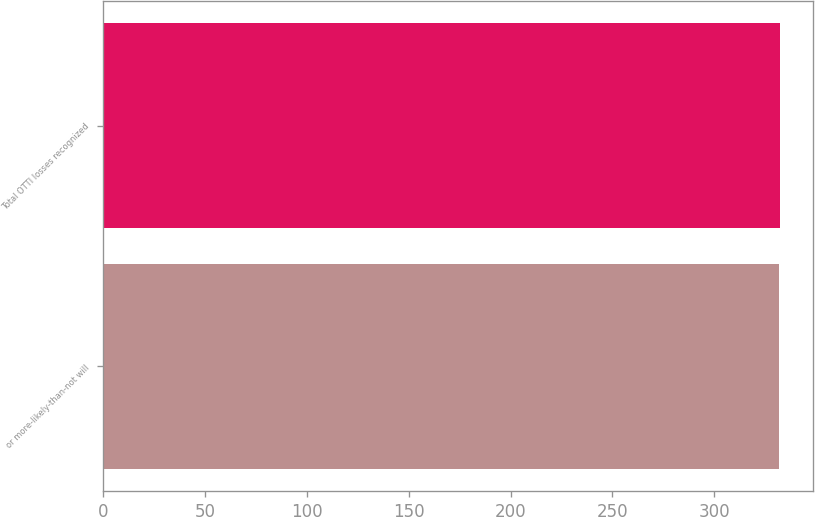Convert chart to OTSL. <chart><loc_0><loc_0><loc_500><loc_500><bar_chart><fcel>or more-likely-than-not will<fcel>Total OTTI losses recognized<nl><fcel>332<fcel>332.1<nl></chart> 